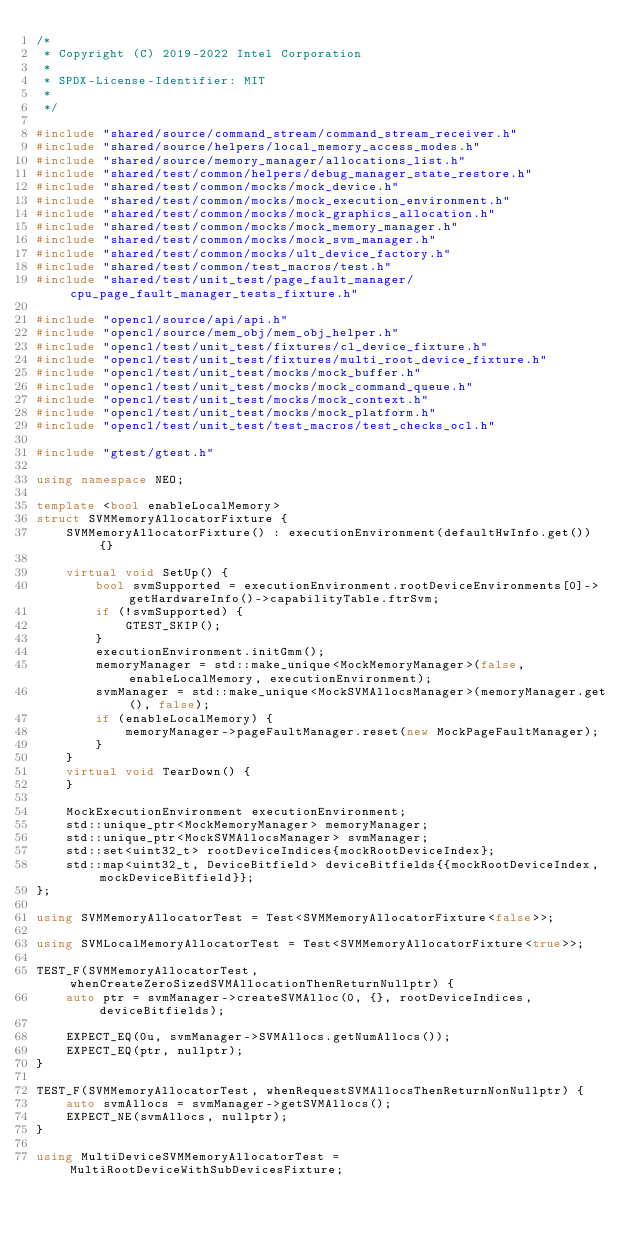Convert code to text. <code><loc_0><loc_0><loc_500><loc_500><_C++_>/*
 * Copyright (C) 2019-2022 Intel Corporation
 *
 * SPDX-License-Identifier: MIT
 *
 */

#include "shared/source/command_stream/command_stream_receiver.h"
#include "shared/source/helpers/local_memory_access_modes.h"
#include "shared/source/memory_manager/allocations_list.h"
#include "shared/test/common/helpers/debug_manager_state_restore.h"
#include "shared/test/common/mocks/mock_device.h"
#include "shared/test/common/mocks/mock_execution_environment.h"
#include "shared/test/common/mocks/mock_graphics_allocation.h"
#include "shared/test/common/mocks/mock_memory_manager.h"
#include "shared/test/common/mocks/mock_svm_manager.h"
#include "shared/test/common/mocks/ult_device_factory.h"
#include "shared/test/common/test_macros/test.h"
#include "shared/test/unit_test/page_fault_manager/cpu_page_fault_manager_tests_fixture.h"

#include "opencl/source/api/api.h"
#include "opencl/source/mem_obj/mem_obj_helper.h"
#include "opencl/test/unit_test/fixtures/cl_device_fixture.h"
#include "opencl/test/unit_test/fixtures/multi_root_device_fixture.h"
#include "opencl/test/unit_test/mocks/mock_buffer.h"
#include "opencl/test/unit_test/mocks/mock_command_queue.h"
#include "opencl/test/unit_test/mocks/mock_context.h"
#include "opencl/test/unit_test/mocks/mock_platform.h"
#include "opencl/test/unit_test/test_macros/test_checks_ocl.h"

#include "gtest/gtest.h"

using namespace NEO;

template <bool enableLocalMemory>
struct SVMMemoryAllocatorFixture {
    SVMMemoryAllocatorFixture() : executionEnvironment(defaultHwInfo.get()) {}

    virtual void SetUp() {
        bool svmSupported = executionEnvironment.rootDeviceEnvironments[0]->getHardwareInfo()->capabilityTable.ftrSvm;
        if (!svmSupported) {
            GTEST_SKIP();
        }
        executionEnvironment.initGmm();
        memoryManager = std::make_unique<MockMemoryManager>(false, enableLocalMemory, executionEnvironment);
        svmManager = std::make_unique<MockSVMAllocsManager>(memoryManager.get(), false);
        if (enableLocalMemory) {
            memoryManager->pageFaultManager.reset(new MockPageFaultManager);
        }
    }
    virtual void TearDown() {
    }

    MockExecutionEnvironment executionEnvironment;
    std::unique_ptr<MockMemoryManager> memoryManager;
    std::unique_ptr<MockSVMAllocsManager> svmManager;
    std::set<uint32_t> rootDeviceIndices{mockRootDeviceIndex};
    std::map<uint32_t, DeviceBitfield> deviceBitfields{{mockRootDeviceIndex, mockDeviceBitfield}};
};

using SVMMemoryAllocatorTest = Test<SVMMemoryAllocatorFixture<false>>;

using SVMLocalMemoryAllocatorTest = Test<SVMMemoryAllocatorFixture<true>>;

TEST_F(SVMMemoryAllocatorTest, whenCreateZeroSizedSVMAllocationThenReturnNullptr) {
    auto ptr = svmManager->createSVMAlloc(0, {}, rootDeviceIndices, deviceBitfields);

    EXPECT_EQ(0u, svmManager->SVMAllocs.getNumAllocs());
    EXPECT_EQ(ptr, nullptr);
}

TEST_F(SVMMemoryAllocatorTest, whenRequestSVMAllocsThenReturnNonNullptr) {
    auto svmAllocs = svmManager->getSVMAllocs();
    EXPECT_NE(svmAllocs, nullptr);
}

using MultiDeviceSVMMemoryAllocatorTest = MultiRootDeviceWithSubDevicesFixture;
</code> 